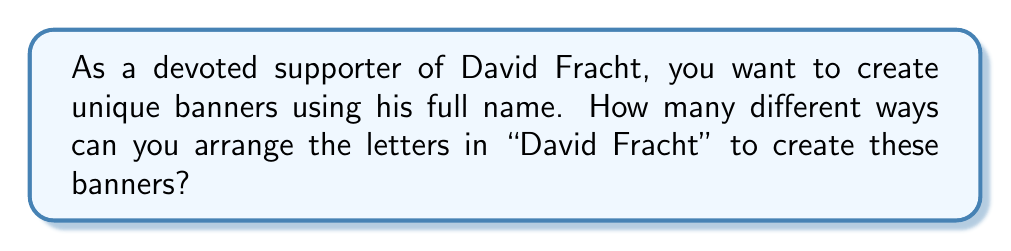Solve this math problem. Let's approach this step-by-step:

1) First, count the total number of letters in "David Fracht":
   There are 11 letters in total.

2) Next, identify repeated letters:
   a: appears 2 times
   d: appears 2 times

3) If all letters were different, we would have 11! arrangements. However, due to repeated letters, we need to account for these.

4) For each repeated letter, we need to divide by the factorial of its frequency to avoid overcounting:
   - For 'a': divide by 2!
   - For 'd': divide by 2!

5) Therefore, the total number of unique arrangements is:

   $$\frac{11!}{(2! \times 2!)}$$

6) Let's calculate this:
   $$\frac{11!}{(2! \times 2!)} = \frac{39,916,800}{4} = 9,979,200$$

Thus, there are 9,979,200 different ways to arrange the letters in "David Fracht".
Answer: 9,979,200 